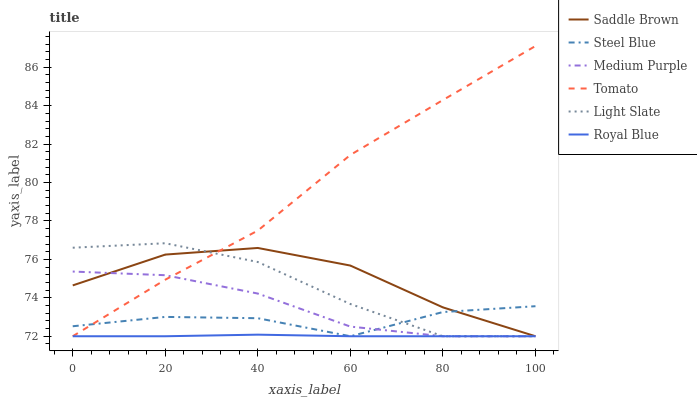Does Royal Blue have the minimum area under the curve?
Answer yes or no. Yes. Does Tomato have the maximum area under the curve?
Answer yes or no. Yes. Does Light Slate have the minimum area under the curve?
Answer yes or no. No. Does Light Slate have the maximum area under the curve?
Answer yes or no. No. Is Royal Blue the smoothest?
Answer yes or no. Yes. Is Light Slate the roughest?
Answer yes or no. Yes. Is Steel Blue the smoothest?
Answer yes or no. No. Is Steel Blue the roughest?
Answer yes or no. No. Does Tomato have the lowest value?
Answer yes or no. Yes. Does Tomato have the highest value?
Answer yes or no. Yes. Does Light Slate have the highest value?
Answer yes or no. No. Does Tomato intersect Medium Purple?
Answer yes or no. Yes. Is Tomato less than Medium Purple?
Answer yes or no. No. Is Tomato greater than Medium Purple?
Answer yes or no. No. 